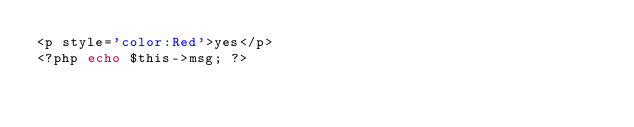<code> <loc_0><loc_0><loc_500><loc_500><_PHP_><p style='color:Red'>yes</p>
<?php echo $this->msg; ?></code> 